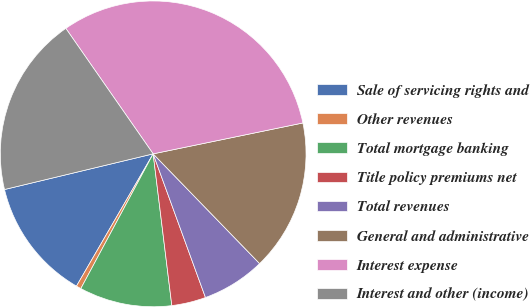<chart> <loc_0><loc_0><loc_500><loc_500><pie_chart><fcel>Sale of servicing rights and<fcel>Other revenues<fcel>Total mortgage banking<fcel>Title policy premiums net<fcel>Total revenues<fcel>General and administrative<fcel>Interest expense<fcel>Interest and other (income)<nl><fcel>12.89%<fcel>0.52%<fcel>9.79%<fcel>3.61%<fcel>6.7%<fcel>15.98%<fcel>31.44%<fcel>19.07%<nl></chart> 